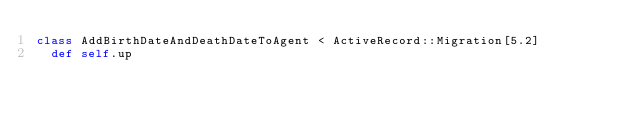Convert code to text. <code><loc_0><loc_0><loc_500><loc_500><_Ruby_>class AddBirthDateAndDeathDateToAgent < ActiveRecord::Migration[5.2]
  def self.up</code> 